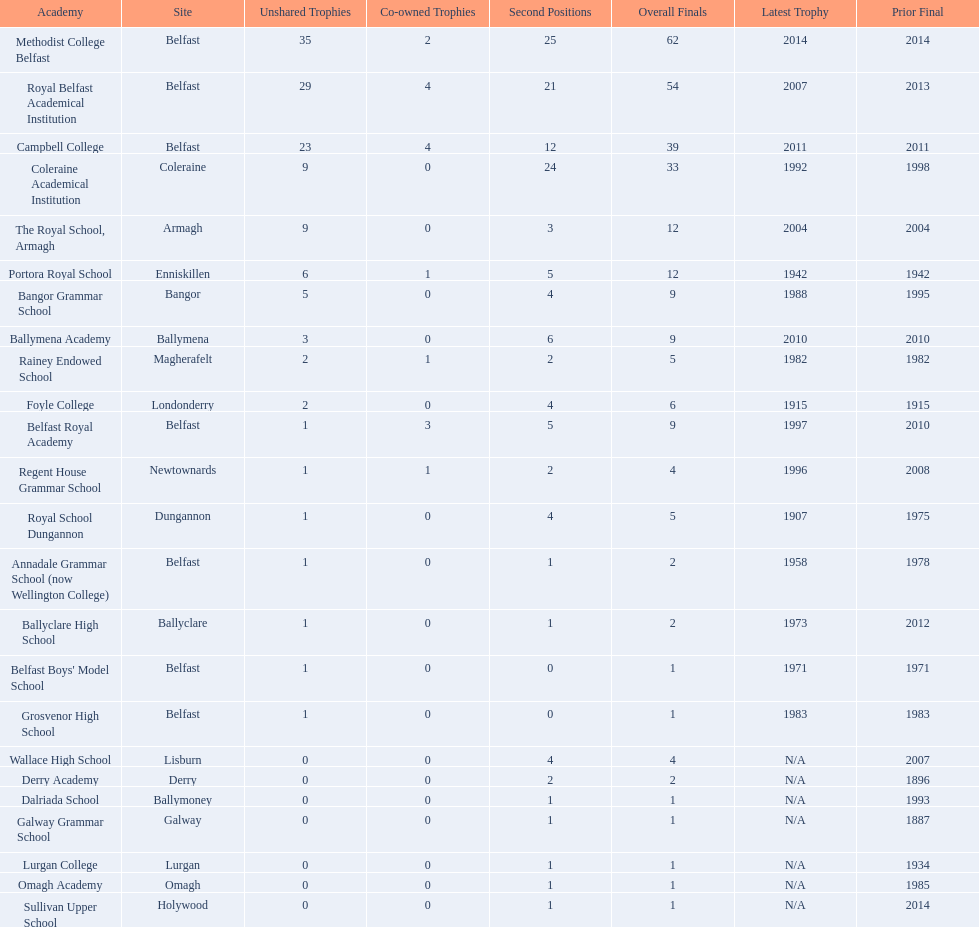Which colleges participated in the ulster's schools' cup? Methodist College Belfast, Royal Belfast Academical Institution, Campbell College, Coleraine Academical Institution, The Royal School, Armagh, Portora Royal School, Bangor Grammar School, Ballymena Academy, Rainey Endowed School, Foyle College, Belfast Royal Academy, Regent House Grammar School, Royal School Dungannon, Annadale Grammar School (now Wellington College), Ballyclare High School, Belfast Boys' Model School, Grosvenor High School, Wallace High School, Derry Academy, Dalriada School, Galway Grammar School, Lurgan College, Omagh Academy, Sullivan Upper School. Of these, which are from belfast? Methodist College Belfast, Royal Belfast Academical Institution, Campbell College, Belfast Royal Academy, Annadale Grammar School (now Wellington College), Belfast Boys' Model School, Grosvenor High School. Of these, which have more than 20 outright titles? Methodist College Belfast, Royal Belfast Academical Institution, Campbell College. Which of these have the fewest runners-up? Campbell College. 